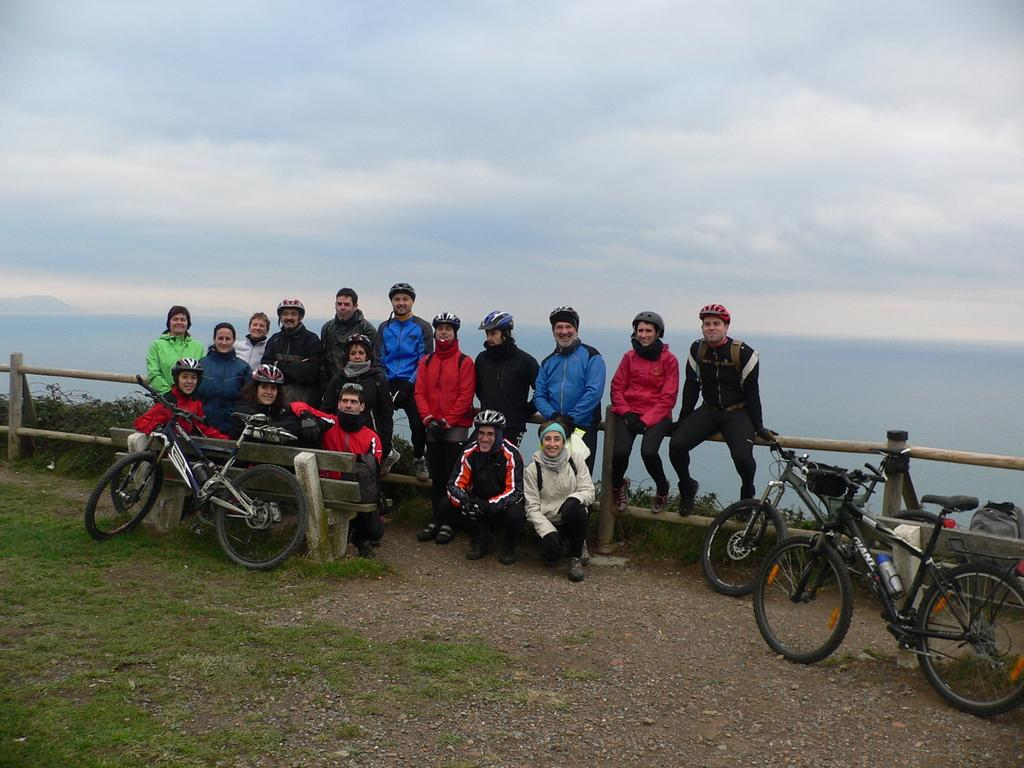How many bicycles are in the image? There are three bicycles in the image. What are the people in the image doing? There is a group of people sitting on a fence in the image. What can be seen in the background of the image? Water and the sky are visible in the background of the image. Where might this image have been taken? The image may have been taken near the ocean, given the presence of water in the background. What rate do the bicycles start at in the image? The image does not provide information about the rate at which the bicycles are moving or starting, as they are stationary in the image. 